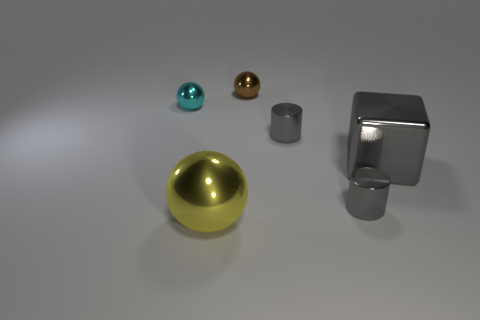There is a thing that is the same size as the yellow shiny sphere; what is it made of?
Make the answer very short. Metal. What color is the other small metal thing that is the same shape as the tiny brown object?
Offer a terse response. Cyan. What material is the sphere in front of the small gray metal cylinder in front of the large block?
Your response must be concise. Metal. There is a small metallic object on the left side of the big yellow sphere; is its shape the same as the small object behind the cyan object?
Your answer should be compact. Yes. There is a shiny object that is both in front of the block and on the left side of the brown metal sphere; how big is it?
Keep it short and to the point. Large. How many other objects are the same color as the block?
Offer a terse response. 2. Is the tiny thing left of the brown metal sphere made of the same material as the yellow object?
Your answer should be compact. Yes. Is there any other thing that is the same size as the yellow object?
Ensure brevity in your answer.  Yes. Is the number of brown balls in front of the large yellow thing less than the number of brown metal objects in front of the cyan metal thing?
Ensure brevity in your answer.  No. Is there anything else that has the same shape as the big yellow metallic object?
Make the answer very short. Yes. 